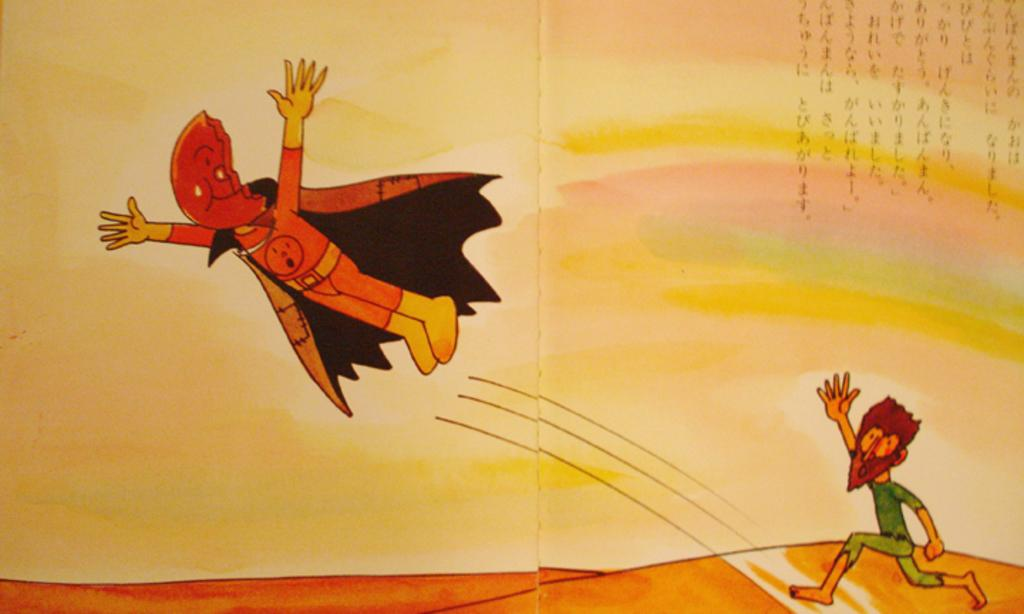What is present on the poster in the image? There is a poster in the image. What type of images are featured on the poster? The poster contains images of people. What else is present on the poster besides the images? There is text on the poster. Can you hear the sound of laughter coming from the wilderness in the image? There is no wilderness or laughter present in the image; it features a poster with images of people and text. How many leaves can be seen on the poster in the image? There are no leaves present on the poster in the image. 